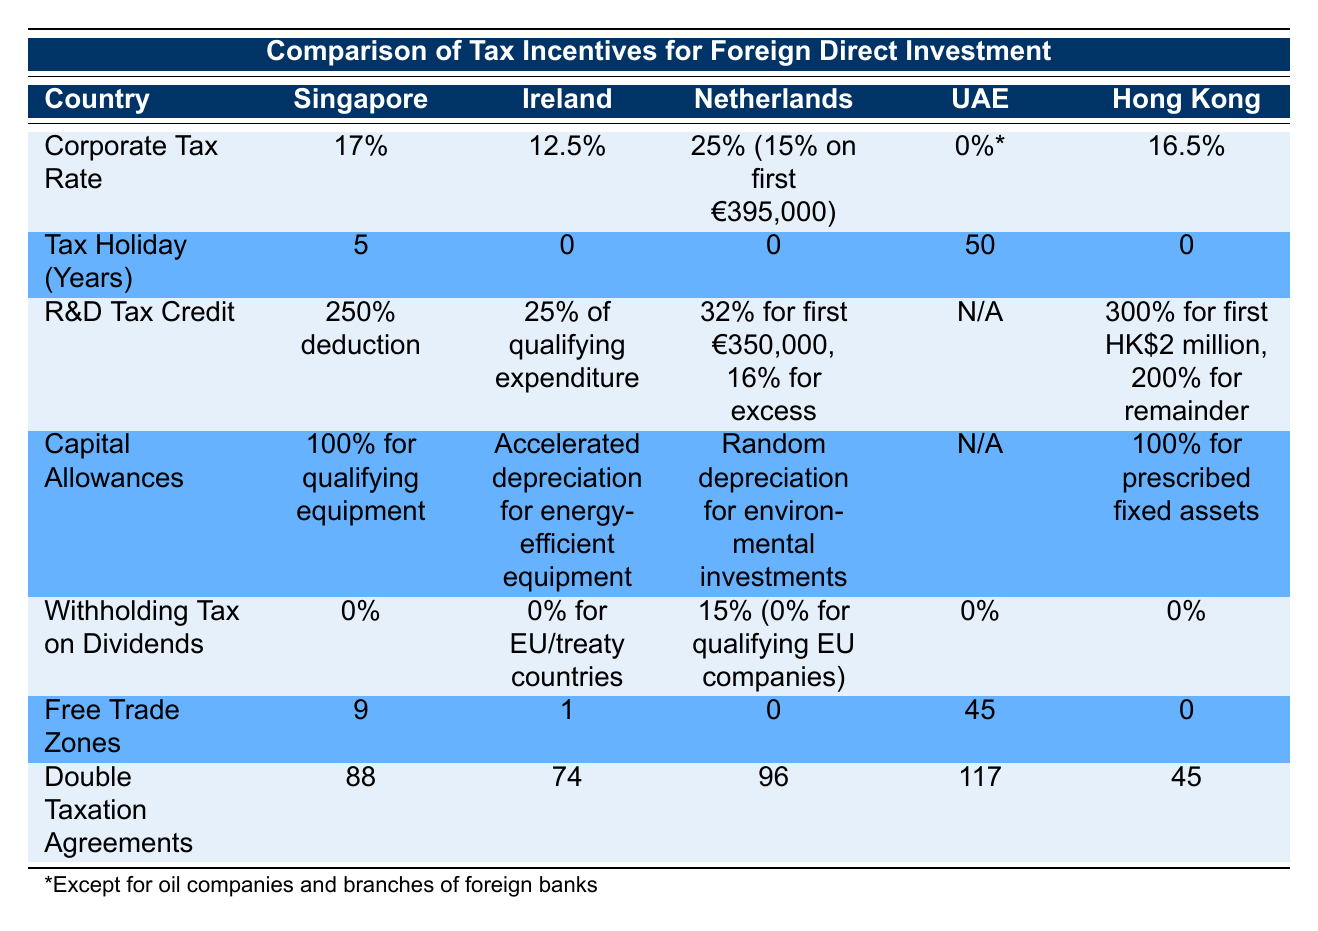What is the corporate tax rate in Singapore? The corporate tax rate for Singapore, as stated in the table, is clearly listed under the corporate tax rate row. It reads "17%."
Answer: 17% How many years of tax holiday does the UAE offer? The table shows that the UAE has a tax holiday of "50" years listed in the tax holiday row.
Answer: 50 Which country offers the highest R&D tax credit percentage? By comparing the R&D tax credit values across the countries, we can see that Singapore offers a "250% deduction," which is higher than others.
Answer: Singapore Is there a country where the withholding tax on dividends is 0%? In the table, we can observe that Singapore, the UAE, and Hong Kong have a withholding tax on dividends listed as "0%." Thus, the answer is yes for these countries.
Answer: Yes What is the average number of free trade zones among these countries? The free trade zones for each country are 9 (Singapore), 1 (Ireland), 0 (Netherlands), 45 (UAE), and 0 (Hong Kong). The sum of these values is 9 + 1 + 0 + 45 + 0 = 55, and with 5 countries, the average is 55/5 = 11.
Answer: 11 Which country has the most double taxation agreements? The double taxation agreements are listed as follows: Singapore has 88, Ireland has 74, Netherlands has 96, UAE has 117, and Hong Kong has 45. The highest number among these values is from the UAE.
Answer: UAE Does Ireland have a tax holiday? Looking at the tax holiday row, Ireland has "0" years listed, indicating that it does not offer a tax holiday.
Answer: No Which country has random depreciation for environmental investments? In the capital allowances row, the Netherlands specifies "Random depreciation for environmental investments."
Answer: Netherlands Is the withholding tax on dividends for countries participating in the EU always 0%? The table indicates that Ireland has "0% for EU/treaty countries," but Netherlands has "15% (0% for qualifying EU companies)." Therefore, it is not always 0%.
Answer: No 